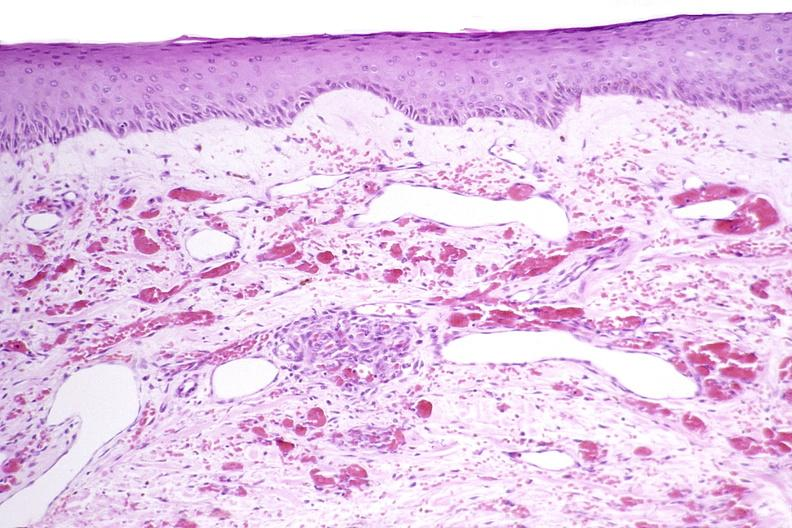what does this image show?
Answer the question using a single word or phrase. Skin 